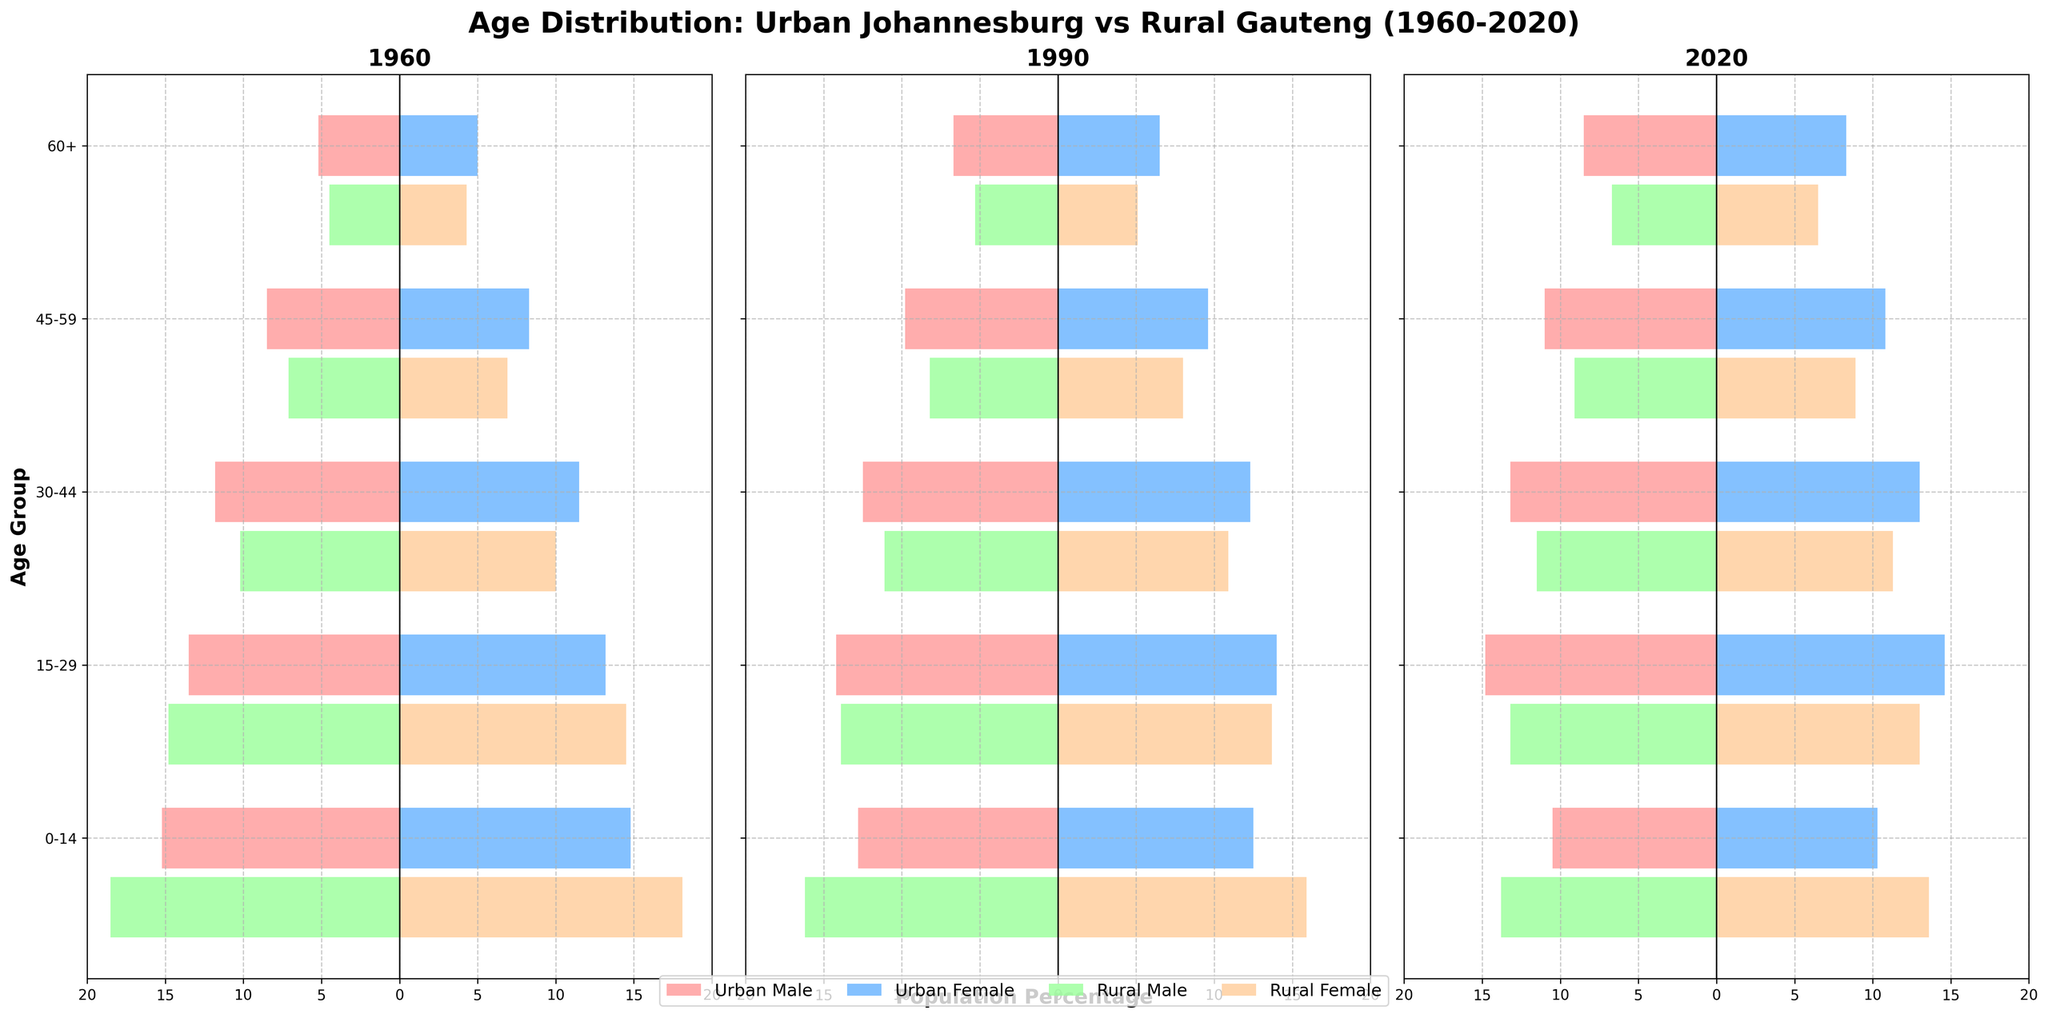What is the title of the figure? The title of the figure is displayed prominently at the top of the chart. It helps the viewer understand the main subject of the visual representation.
Answer: Age Distribution: Urban Johannesburg vs Rural Gauteng (1960-2020) Which age group had the highest percentage of the population in Urban Johannesburg in 1960? By looking at the bars representing 1960 in Urban Johannesburg, the longest bar indicates the age group with the highest percentage. This isn't a detailed calculation but an observation of the length of the bars.
Answer: 0-14 How did the population percentage of the 0-14 age group in Urban Johannesburg change from 1960 to 2020? In 1960, the population percentage is 15.2% (male) and 14.8% (female). In 2020, it is 10.5% (male) and 10.3% (female). There is a decline in both male and female percentages over these years.
Answer: Declined Which age group saw the most considerable increase in population percentage within Urban Johannesburg from 1960 to 2020? To determine this, we look at each age group's percentage in 1960 and 2020 and compare them to find the age group with the most significant increase. The 60+ age group increases from 5.2% (male) and 5.0% (female) in 1960 to 8.5% (male) and 8.3% (female) in 2020.
Answer: 60+ In 1990, which age group had a higher population percentage in Rural Gauteng, males or females? For 1990, compare the percentage values listed for males and females within each age group. For all groups, the female percentages are slightly lower than the male percentages, except for 30-44 where females (10.9%) are slightly above males (11.1%).
Answer: Males (for most age groups except 30-44) How does the population distribution of the 30-44 age group in Urban Johannesburg compare to Rural Gauteng in 2020? Compare the percentage bars for the 30-44 age group in 2020 for both Urban Johannesburg and Rural Gauteng. Urban Johannesburg has 13.2% (male) and 13.0% (female), whereas Rural Gauteng has 11.5% (male) and 11.3% (female).
Answer: Higher in Urban Johannesburg What is the change in population percentage for the 15-29 age group in Rural Gauteng from 1960 to 1990? In 1960, the percentages are 14.8% (male) and 14.5% (female). In 1990, they are 13.9% (male) and 13.7% (female). By calculating the differences, we see a decrease: male by 0.9% and female by 0.8%.
Answer: Decrease by 0.9% (male) and 0.8% (female) Which age group in Rural Gauteng maintained the most stable population percentage for both males and females from 1960 to 2020? By comparing the percentages for each age group in the Rural Gauteng dataset across the three years, we see that the 15-29 age group has minimal changes across 1960 (14.8% male, 14.5% female), 1990 (13.9% male, 13.7% female), and 2020 (13.2% male, 13.0% female).
Answer: 15-29 In which year did the 45-59 age group in Urban Johannesburg first surpass a 10% population percentage for both males and females? By observing the bars for the 45-59 age group across different years, we note that in 1960 and 1990, the percentages are below 10%. In 2020, the percentages are 11.0% (male) and 10.8% (female).
Answer: 2020 